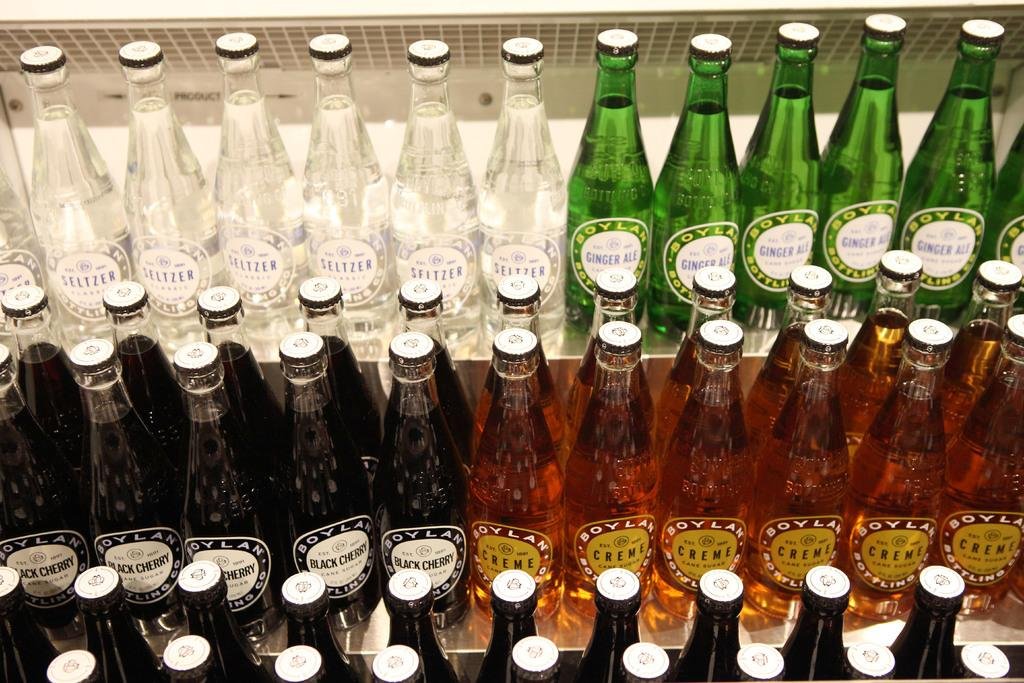<image>
Relay a brief, clear account of the picture shown. Bottles of Seltzer, Ginger Ale, Black Cherry, Creme by Boylan Brewing Co. 